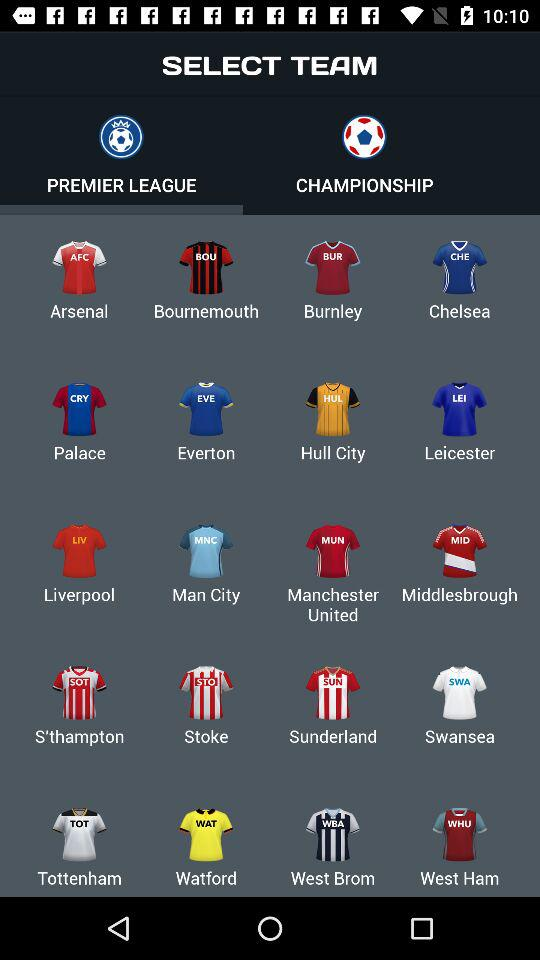How many teams are in the Premier League?
Answer the question using a single word or phrase. 20 